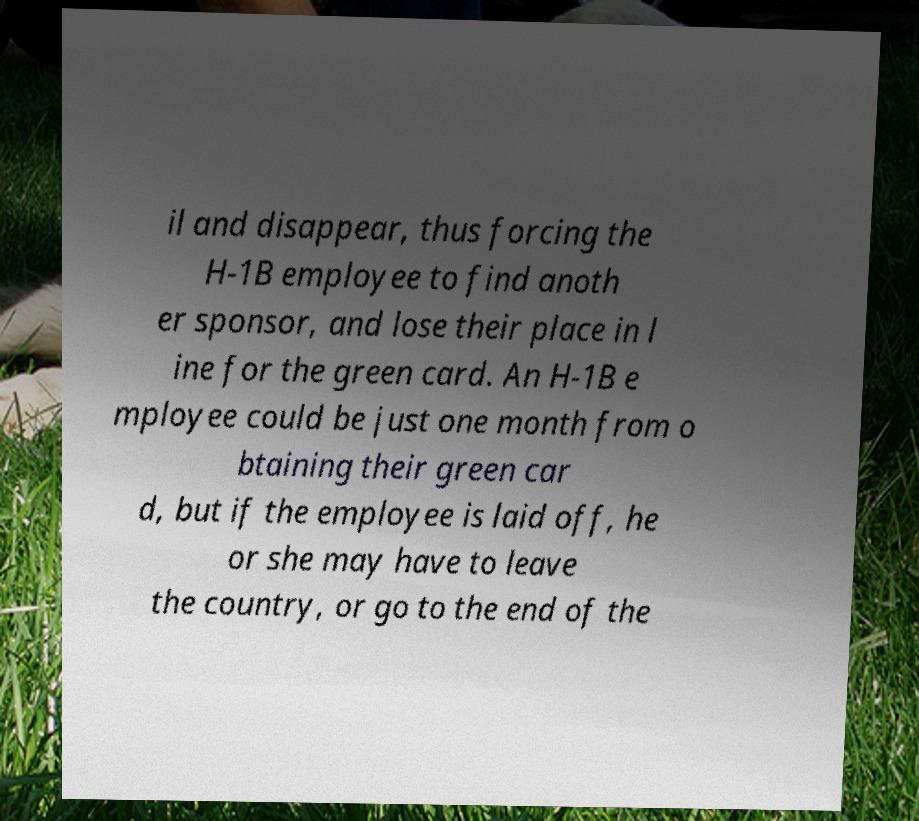What messages or text are displayed in this image? I need them in a readable, typed format. il and disappear, thus forcing the H-1B employee to find anoth er sponsor, and lose their place in l ine for the green card. An H-1B e mployee could be just one month from o btaining their green car d, but if the employee is laid off, he or she may have to leave the country, or go to the end of the 